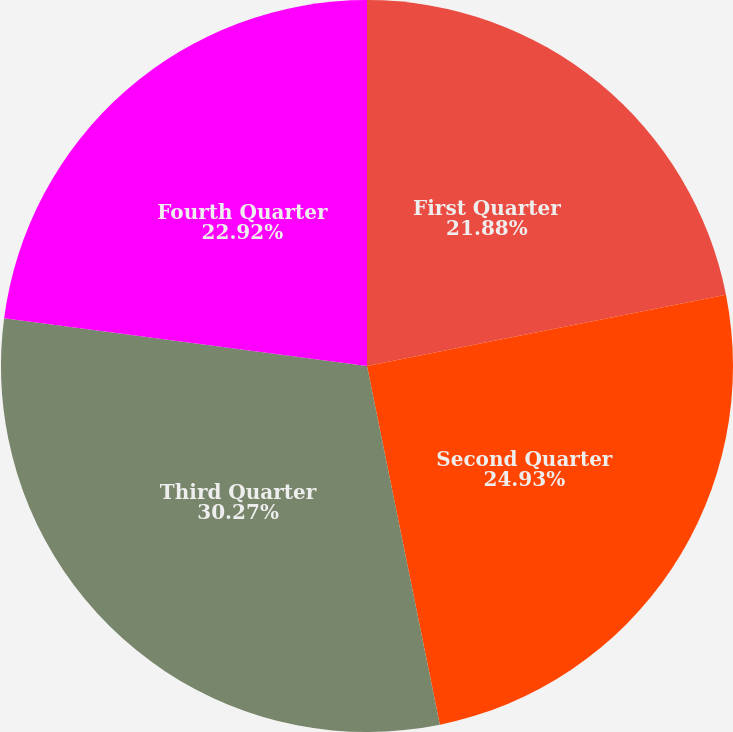Convert chart. <chart><loc_0><loc_0><loc_500><loc_500><pie_chart><fcel>First Quarter<fcel>Second Quarter<fcel>Third Quarter<fcel>Fourth Quarter<nl><fcel>21.88%<fcel>24.93%<fcel>30.27%<fcel>22.92%<nl></chart> 